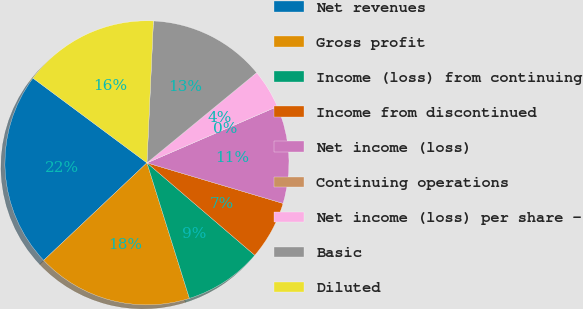<chart> <loc_0><loc_0><loc_500><loc_500><pie_chart><fcel>Net revenues<fcel>Gross profit<fcel>Income (loss) from continuing<fcel>Income from discontinued<fcel>Net income (loss)<fcel>Continuing operations<fcel>Net income (loss) per share -<fcel>Basic<fcel>Diluted<nl><fcel>22.22%<fcel>17.79%<fcel>8.89%<fcel>6.67%<fcel>11.11%<fcel>0.0%<fcel>4.45%<fcel>13.33%<fcel>15.55%<nl></chart> 